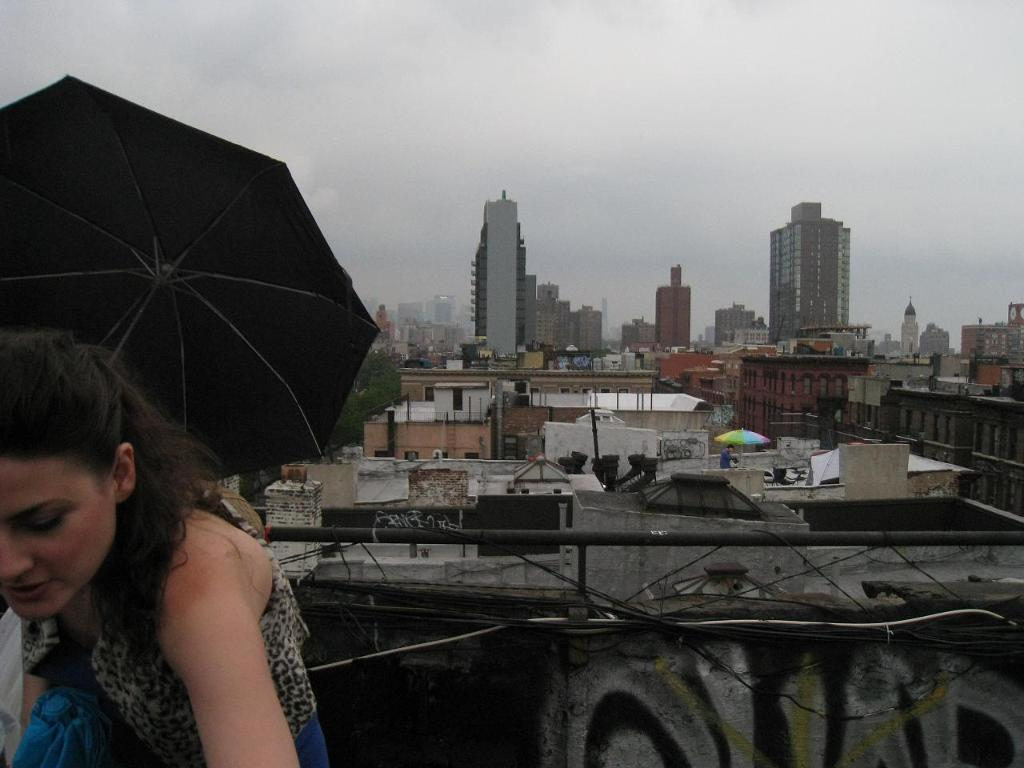Who is the person standing on the left side of the image? There is a woman standing on the left side of the image. What is the woman standing on? The woman is standing on a bungalow. What can be seen in the background of the image? Many buildings and homes are visible in the background of the image. What is visible in the sky in the image? The sky is visible in the image. What key is the woman holding in her hand in the image? There is no key visible in the woman's hand in the image. What does the woman hate about the buildings in the background? The image does not provide any information about the woman's feelings or emotions towards the buildings in the background. 